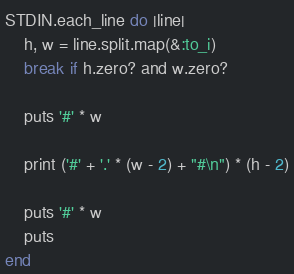Convert code to text. <code><loc_0><loc_0><loc_500><loc_500><_Ruby_>STDIN.each_line do |line|
	h, w = line.split.map(&:to_i)
	break if h.zero? and w.zero?

	puts '#' * w

	print ('#' + '.' * (w - 2) + "#\n") * (h - 2)

	puts '#' * w
	puts
end</code> 